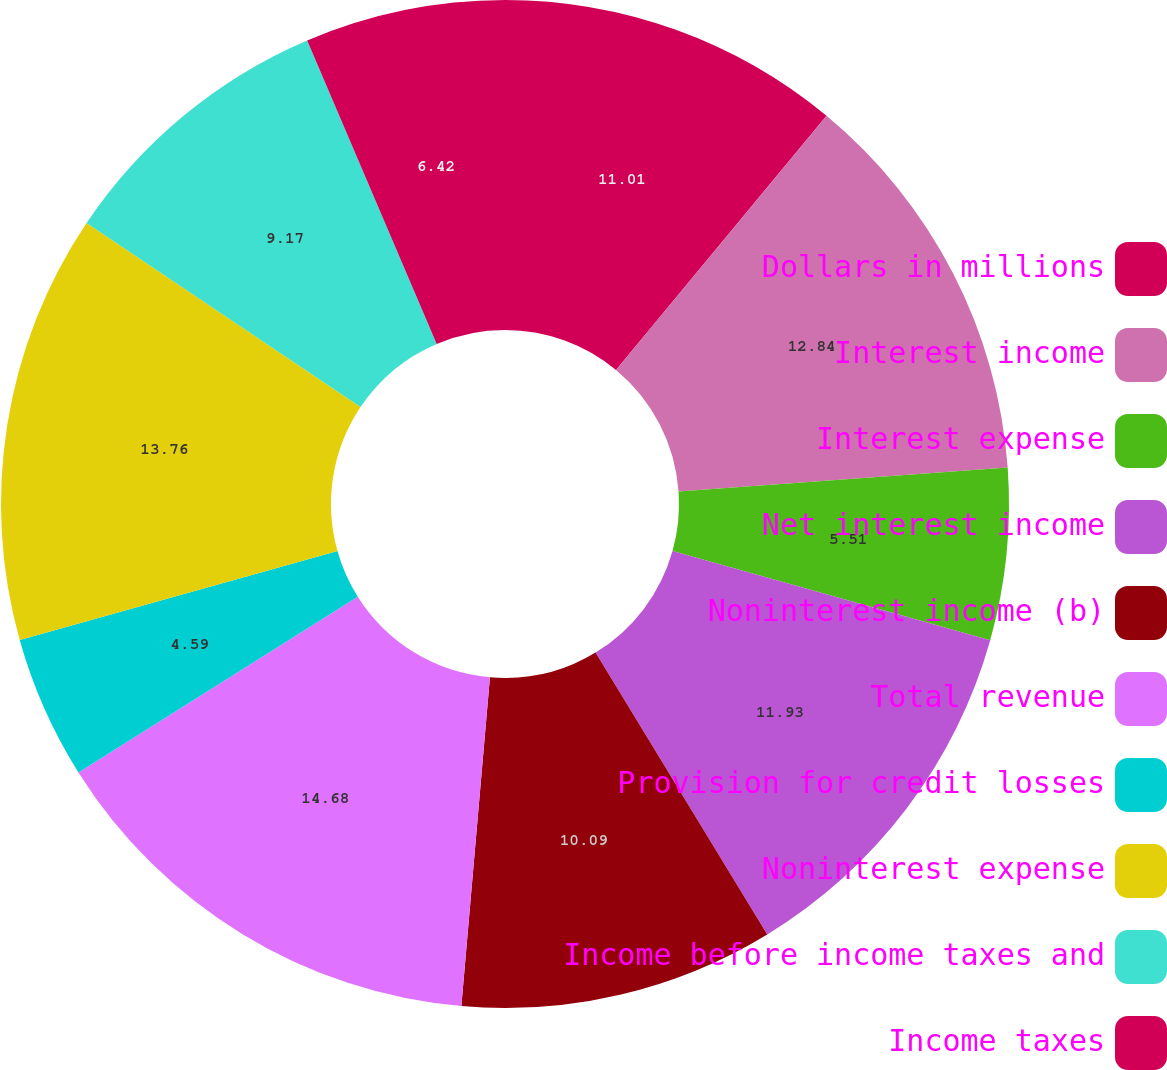Convert chart to OTSL. <chart><loc_0><loc_0><loc_500><loc_500><pie_chart><fcel>Dollars in millions<fcel>Interest income<fcel>Interest expense<fcel>Net interest income<fcel>Noninterest income (b)<fcel>Total revenue<fcel>Provision for credit losses<fcel>Noninterest expense<fcel>Income before income taxes and<fcel>Income taxes<nl><fcel>11.01%<fcel>12.84%<fcel>5.51%<fcel>11.93%<fcel>10.09%<fcel>14.68%<fcel>4.59%<fcel>13.76%<fcel>9.17%<fcel>6.42%<nl></chart> 